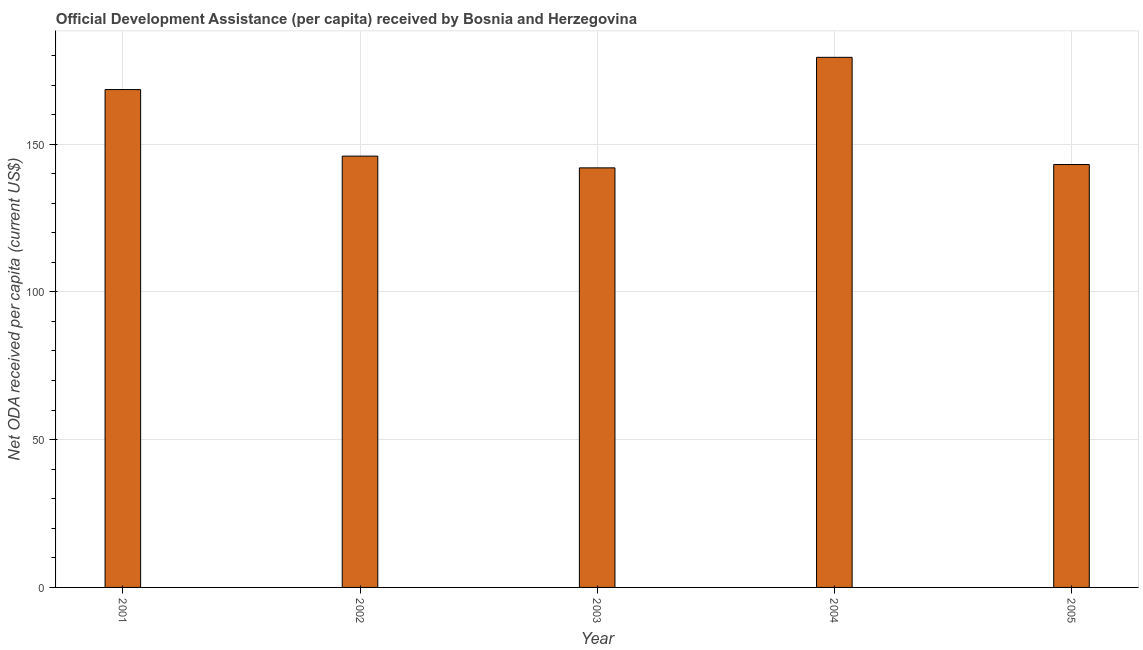What is the title of the graph?
Offer a very short reply. Official Development Assistance (per capita) received by Bosnia and Herzegovina. What is the label or title of the Y-axis?
Offer a very short reply. Net ODA received per capita (current US$). What is the net oda received per capita in 2002?
Give a very brief answer. 145.94. Across all years, what is the maximum net oda received per capita?
Provide a succinct answer. 179.36. Across all years, what is the minimum net oda received per capita?
Offer a terse response. 141.96. In which year was the net oda received per capita minimum?
Your answer should be very brief. 2003. What is the sum of the net oda received per capita?
Give a very brief answer. 778.81. What is the difference between the net oda received per capita in 2002 and 2005?
Provide a short and direct response. 2.85. What is the average net oda received per capita per year?
Give a very brief answer. 155.76. What is the median net oda received per capita?
Give a very brief answer. 145.94. What is the ratio of the net oda received per capita in 2001 to that in 2003?
Keep it short and to the point. 1.19. Is the difference between the net oda received per capita in 2001 and 2003 greater than the difference between any two years?
Give a very brief answer. No. What is the difference between the highest and the second highest net oda received per capita?
Offer a terse response. 10.91. What is the difference between the highest and the lowest net oda received per capita?
Provide a succinct answer. 37.4. How many bars are there?
Your response must be concise. 5. Are all the bars in the graph horizontal?
Keep it short and to the point. No. What is the difference between two consecutive major ticks on the Y-axis?
Provide a succinct answer. 50. Are the values on the major ticks of Y-axis written in scientific E-notation?
Your answer should be very brief. No. What is the Net ODA received per capita (current US$) in 2001?
Provide a short and direct response. 168.45. What is the Net ODA received per capita (current US$) of 2002?
Your answer should be very brief. 145.94. What is the Net ODA received per capita (current US$) in 2003?
Keep it short and to the point. 141.96. What is the Net ODA received per capita (current US$) of 2004?
Offer a very short reply. 179.36. What is the Net ODA received per capita (current US$) of 2005?
Your response must be concise. 143.09. What is the difference between the Net ODA received per capita (current US$) in 2001 and 2002?
Give a very brief answer. 22.52. What is the difference between the Net ODA received per capita (current US$) in 2001 and 2003?
Ensure brevity in your answer.  26.49. What is the difference between the Net ODA received per capita (current US$) in 2001 and 2004?
Ensure brevity in your answer.  -10.91. What is the difference between the Net ODA received per capita (current US$) in 2001 and 2005?
Make the answer very short. 25.36. What is the difference between the Net ODA received per capita (current US$) in 2002 and 2003?
Provide a short and direct response. 3.97. What is the difference between the Net ODA received per capita (current US$) in 2002 and 2004?
Your response must be concise. -33.43. What is the difference between the Net ODA received per capita (current US$) in 2002 and 2005?
Offer a terse response. 2.85. What is the difference between the Net ODA received per capita (current US$) in 2003 and 2004?
Your response must be concise. -37.4. What is the difference between the Net ODA received per capita (current US$) in 2003 and 2005?
Keep it short and to the point. -1.13. What is the difference between the Net ODA received per capita (current US$) in 2004 and 2005?
Make the answer very short. 36.27. What is the ratio of the Net ODA received per capita (current US$) in 2001 to that in 2002?
Your response must be concise. 1.15. What is the ratio of the Net ODA received per capita (current US$) in 2001 to that in 2003?
Your answer should be compact. 1.19. What is the ratio of the Net ODA received per capita (current US$) in 2001 to that in 2004?
Provide a short and direct response. 0.94. What is the ratio of the Net ODA received per capita (current US$) in 2001 to that in 2005?
Ensure brevity in your answer.  1.18. What is the ratio of the Net ODA received per capita (current US$) in 2002 to that in 2003?
Make the answer very short. 1.03. What is the ratio of the Net ODA received per capita (current US$) in 2002 to that in 2004?
Offer a very short reply. 0.81. What is the ratio of the Net ODA received per capita (current US$) in 2003 to that in 2004?
Make the answer very short. 0.79. What is the ratio of the Net ODA received per capita (current US$) in 2004 to that in 2005?
Offer a terse response. 1.25. 